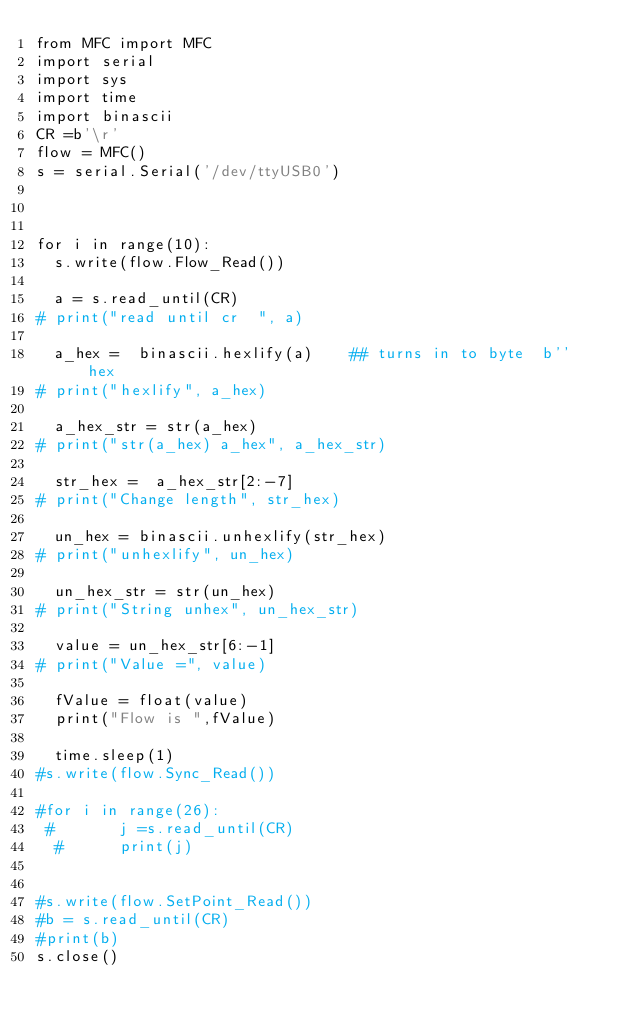<code> <loc_0><loc_0><loc_500><loc_500><_Python_>from MFC import MFC
import serial
import sys
import time
import binascii
CR =b'\r'
flow = MFC()
s = serial.Serial('/dev/ttyUSB0')



for i in range(10):
	s.write(flow.Flow_Read())

	a = s.read_until(CR)
#	print("read until cr  ", a)

	a_hex =  binascii.hexlify(a)    ## turns in to byte  b''  hex
#	print("hexlify", a_hex)

	a_hex_str = str(a_hex)
#	print("str(a_hex) a_hex", a_hex_str)

	str_hex =  a_hex_str[2:-7]
#	print("Change length", str_hex)

	un_hex = binascii.unhexlify(str_hex)
#	print("unhexlify", un_hex)

	un_hex_str = str(un_hex)
#	print("String unhex", un_hex_str)

	value = un_hex_str[6:-1]
#	print("Value =", value)

	fValue = float(value)
	print("Flow is ",fValue)

	time.sleep(1)
#s.write(flow.Sync_Read())

#for i in range(26):
 #       j =s.read_until(CR)
  #      print(j)


#s.write(flow.SetPoint_Read())
#b = s.read_until(CR)
#print(b)
s.close()

</code> 